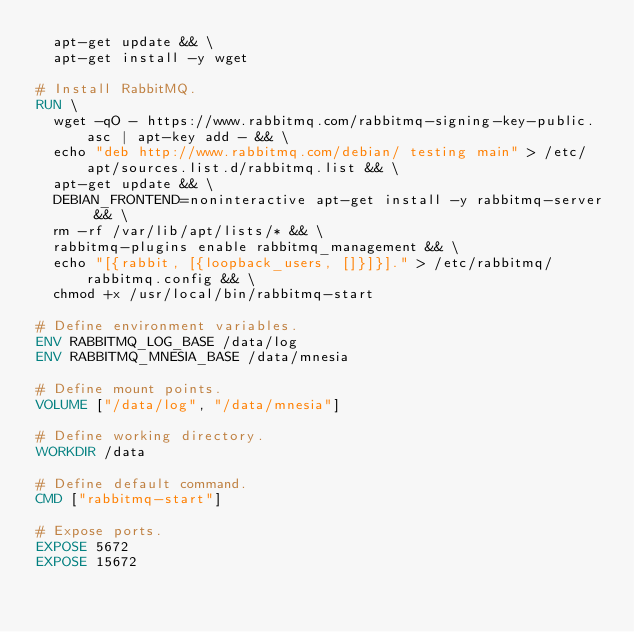<code> <loc_0><loc_0><loc_500><loc_500><_Dockerfile_>  apt-get update && \
  apt-get install -y wget

# Install RabbitMQ.
RUN \
  wget -qO - https://www.rabbitmq.com/rabbitmq-signing-key-public.asc | apt-key add - && \
  echo "deb http://www.rabbitmq.com/debian/ testing main" > /etc/apt/sources.list.d/rabbitmq.list && \
  apt-get update && \
  DEBIAN_FRONTEND=noninteractive apt-get install -y rabbitmq-server && \
  rm -rf /var/lib/apt/lists/* && \
  rabbitmq-plugins enable rabbitmq_management && \
  echo "[{rabbit, [{loopback_users, []}]}]." > /etc/rabbitmq/rabbitmq.config && \
  chmod +x /usr/local/bin/rabbitmq-start

# Define environment variables.
ENV RABBITMQ_LOG_BASE /data/log
ENV RABBITMQ_MNESIA_BASE /data/mnesia

# Define mount points.
VOLUME ["/data/log", "/data/mnesia"]

# Define working directory.
WORKDIR /data

# Define default command.
CMD ["rabbitmq-start"]

# Expose ports.
EXPOSE 5672
EXPOSE 15672
</code> 